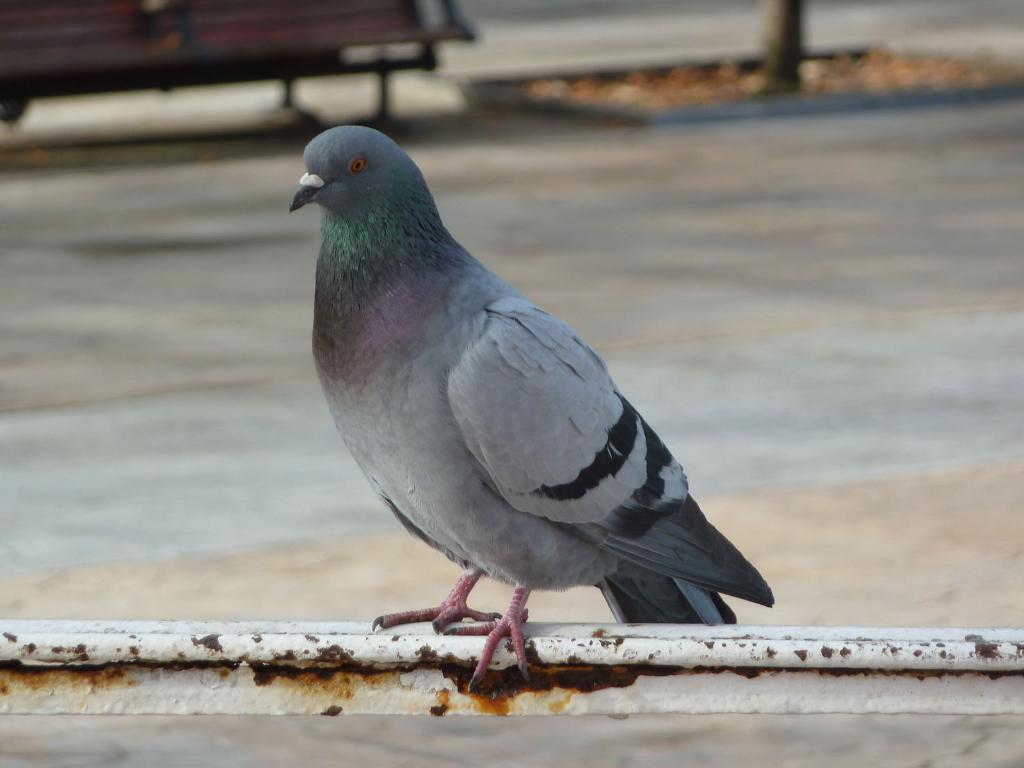In one or two sentences, can you explain what this image depicts? In the foreground of the picture there is a pigeon on an iron bar. The background is blurred. The background there are pavement, bench, tree and dry leaves. 